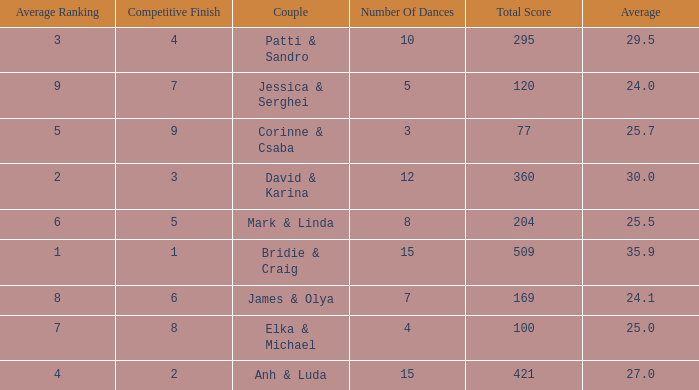What is the average for the couple anh & luda? 27.0. 